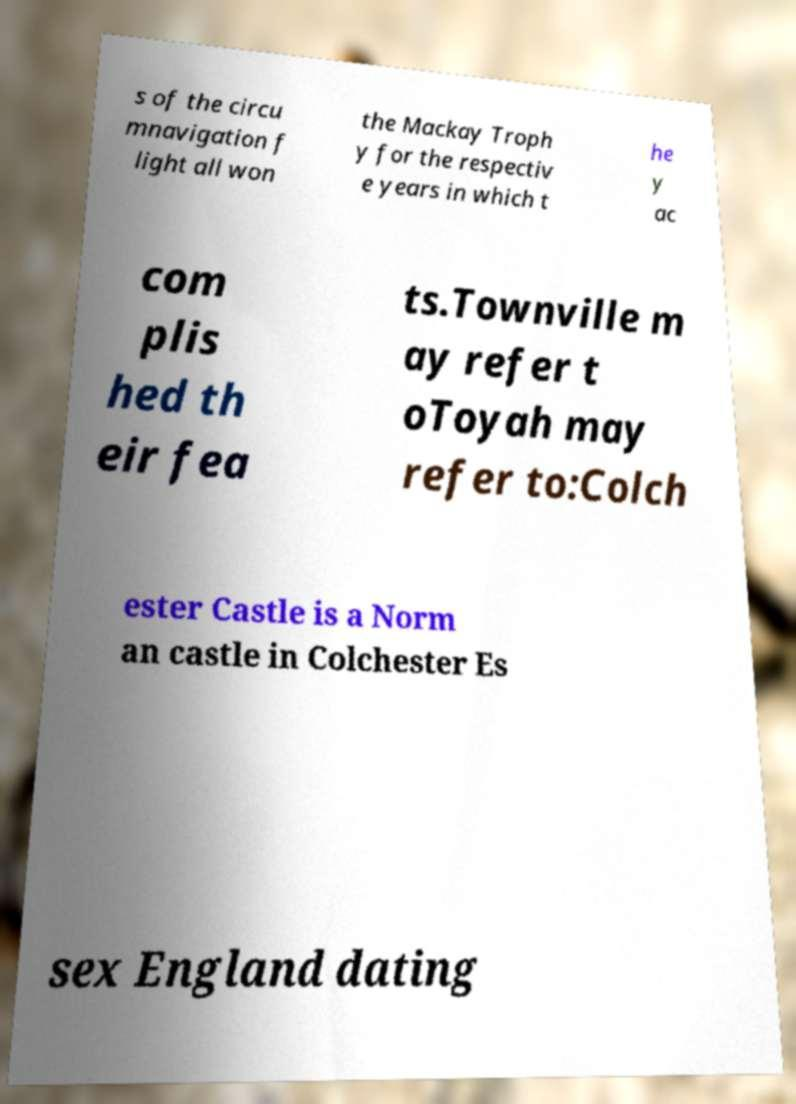Could you assist in decoding the text presented in this image and type it out clearly? s of the circu mnavigation f light all won the Mackay Troph y for the respectiv e years in which t he y ac com plis hed th eir fea ts.Townville m ay refer t oToyah may refer to:Colch ester Castle is a Norm an castle in Colchester Es sex England dating 